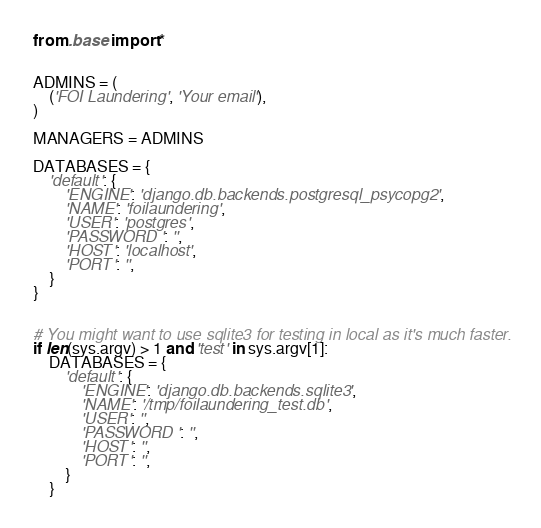Convert code to text. <code><loc_0><loc_0><loc_500><loc_500><_Python_>from .base import *


ADMINS = (
    ('FOI Laundering', 'Your email'),
)

MANAGERS = ADMINS

DATABASES = {
    'default': {
        'ENGINE': 'django.db.backends.postgresql_psycopg2',
        'NAME': 'foilaundering',
        'USER': 'postgres',
        'PASSWORD': '',
        'HOST': 'localhost',
        'PORT': '',
    }
}


# You might want to use sqlite3 for testing in local as it's much faster.
if len(sys.argv) > 1 and 'test' in sys.argv[1]:
    DATABASES = {
        'default': {
            'ENGINE': 'django.db.backends.sqlite3',
            'NAME': '/tmp/foilaundering_test.db',
            'USER': '',
            'PASSWORD': '',
            'HOST': '',
            'PORT': '',
        }
    }
</code> 